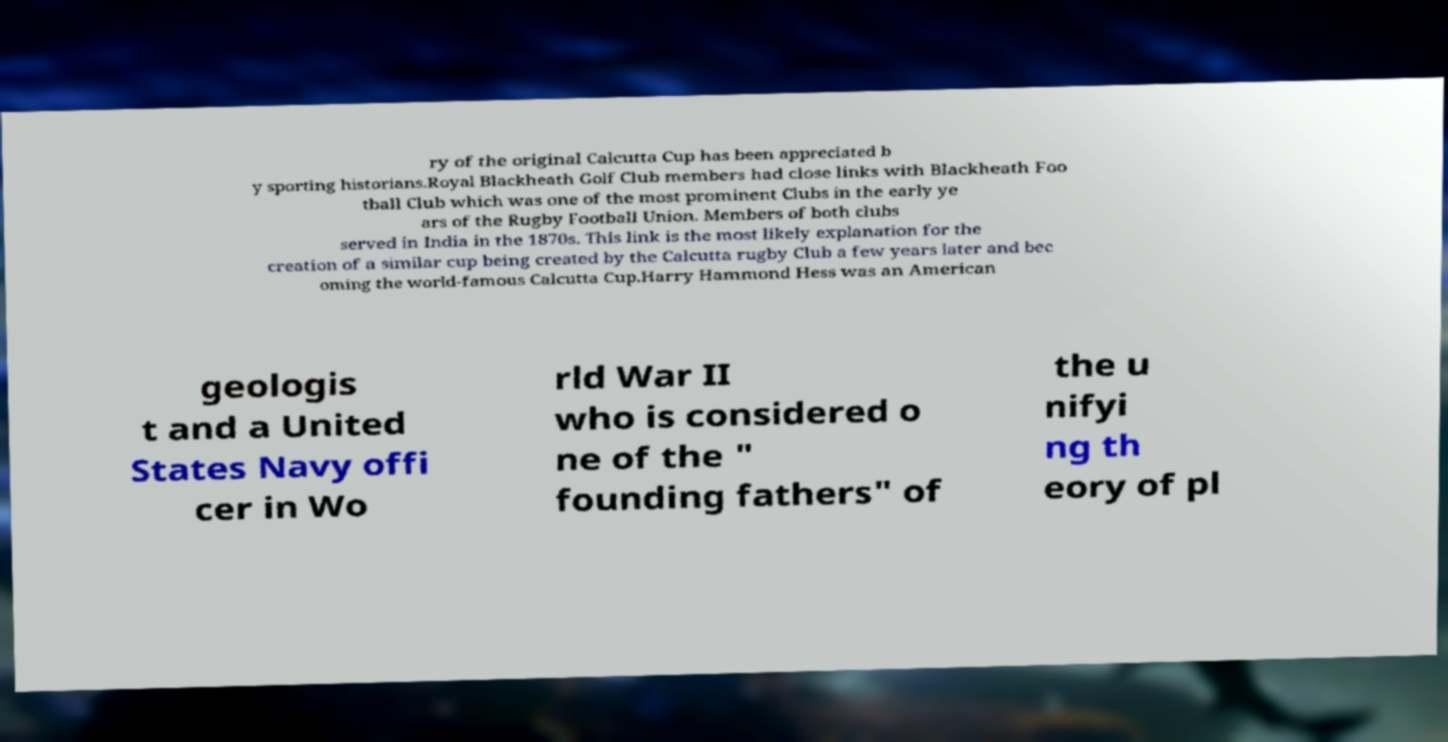Can you read and provide the text displayed in the image?This photo seems to have some interesting text. Can you extract and type it out for me? ry of the original Calcutta Cup has been appreciated b y sporting historians.Royal Blackheath Golf Club members had close links with Blackheath Foo tball Club which was one of the most prominent Clubs in the early ye ars of the Rugby Football Union. Members of both clubs served in India in the 1870s. This link is the most likely explanation for the creation of a similar cup being created by the Calcutta rugby Club a few years later and bec oming the world-famous Calcutta Cup.Harry Hammond Hess was an American geologis t and a United States Navy offi cer in Wo rld War II who is considered o ne of the " founding fathers" of the u nifyi ng th eory of pl 